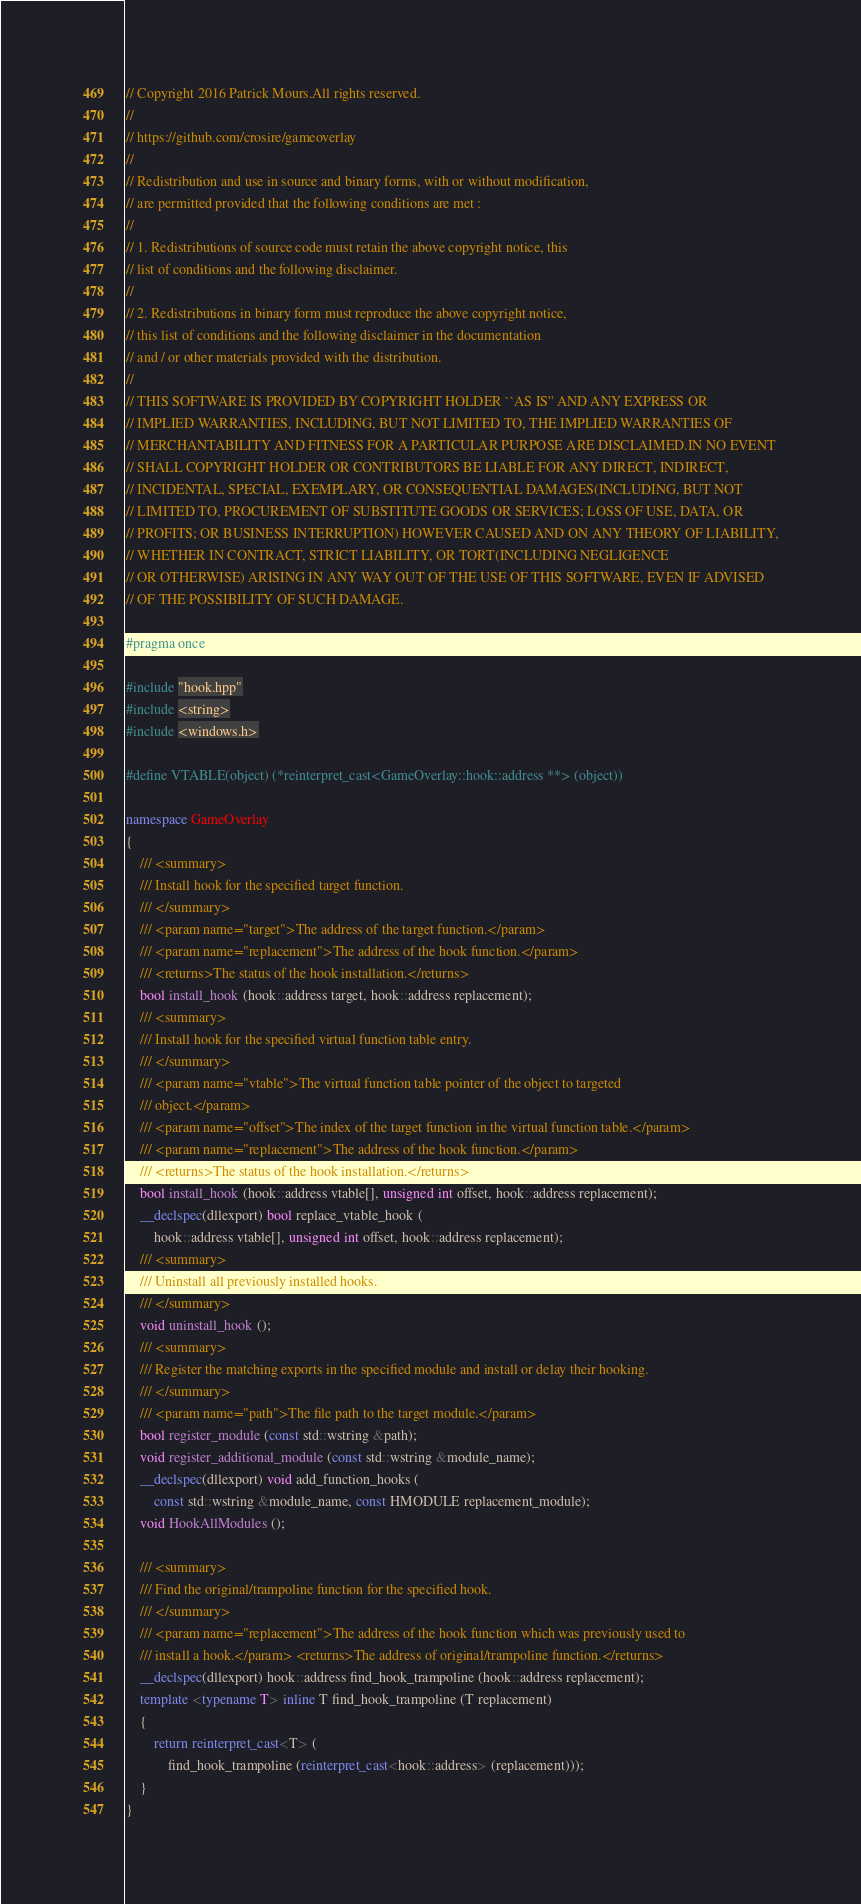Convert code to text. <code><loc_0><loc_0><loc_500><loc_500><_C++_>// Copyright 2016 Patrick Mours.All rights reserved.
//
// https://github.com/crosire/gameoverlay
//
// Redistribution and use in source and binary forms, with or without modification,
// are permitted provided that the following conditions are met :
//
// 1. Redistributions of source code must retain the above copyright notice, this
// list of conditions and the following disclaimer.
//
// 2. Redistributions in binary form must reproduce the above copyright notice,
// this list of conditions and the following disclaimer in the documentation
// and / or other materials provided with the distribution.
//
// THIS SOFTWARE IS PROVIDED BY COPYRIGHT HOLDER ``AS IS'' AND ANY EXPRESS OR
// IMPLIED WARRANTIES, INCLUDING, BUT NOT LIMITED TO, THE IMPLIED WARRANTIES OF
// MERCHANTABILITY AND FITNESS FOR A PARTICULAR PURPOSE ARE DISCLAIMED.IN NO EVENT
// SHALL COPYRIGHT HOLDER OR CONTRIBUTORS BE LIABLE FOR ANY DIRECT, INDIRECT,
// INCIDENTAL, SPECIAL, EXEMPLARY, OR CONSEQUENTIAL DAMAGES(INCLUDING, BUT NOT
// LIMITED TO, PROCUREMENT OF SUBSTITUTE GOODS OR SERVICES; LOSS OF USE, DATA, OR
// PROFITS; OR BUSINESS INTERRUPTION) HOWEVER CAUSED AND ON ANY THEORY OF LIABILITY,
// WHETHER IN CONTRACT, STRICT LIABILITY, OR TORT(INCLUDING NEGLIGENCE
// OR OTHERWISE) ARISING IN ANY WAY OUT OF THE USE OF THIS SOFTWARE, EVEN IF ADVISED
// OF THE POSSIBILITY OF SUCH DAMAGE.

#pragma once

#include "hook.hpp"
#include <string>
#include <windows.h>

#define VTABLE(object) (*reinterpret_cast<GameOverlay::hook::address **> (object))

namespace GameOverlay
{
    /// <summary>
    /// Install hook for the specified target function.
    /// </summary>
    /// <param name="target">The address of the target function.</param>
    /// <param name="replacement">The address of the hook function.</param>
    /// <returns>The status of the hook installation.</returns>
    bool install_hook (hook::address target, hook::address replacement);
    /// <summary>
    /// Install hook for the specified virtual function table entry.
    /// </summary>
    /// <param name="vtable">The virtual function table pointer of the object to targeted
    /// object.</param>
    /// <param name="offset">The index of the target function in the virtual function table.</param>
    /// <param name="replacement">The address of the hook function.</param>
    /// <returns>The status of the hook installation.</returns>
    bool install_hook (hook::address vtable[], unsigned int offset, hook::address replacement);
    __declspec(dllexport) bool replace_vtable_hook (
        hook::address vtable[], unsigned int offset, hook::address replacement);
    /// <summary>
    /// Uninstall all previously installed hooks.
    /// </summary>
    void uninstall_hook ();
    /// <summary>
    /// Register the matching exports in the specified module and install or delay their hooking.
    /// </summary>
    /// <param name="path">The file path to the target module.</param>
    bool register_module (const std::wstring &path);
    void register_additional_module (const std::wstring &module_name);
    __declspec(dllexport) void add_function_hooks (
        const std::wstring &module_name, const HMODULE replacement_module);
    void HookAllModules ();

    /// <summary>
    /// Find the original/trampoline function for the specified hook.
    /// </summary>
    /// <param name="replacement">The address of the hook function which was previously used to
    /// install a hook.</param> <returns>The address of original/trampoline function.</returns>
    __declspec(dllexport) hook::address find_hook_trampoline (hook::address replacement);
    template <typename T> inline T find_hook_trampoline (T replacement)
    {
        return reinterpret_cast<T> (
            find_hook_trampoline (reinterpret_cast<hook::address> (replacement)));
    }
}
</code> 